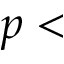Convert formula to latex. <formula><loc_0><loc_0><loc_500><loc_500>p <</formula> 